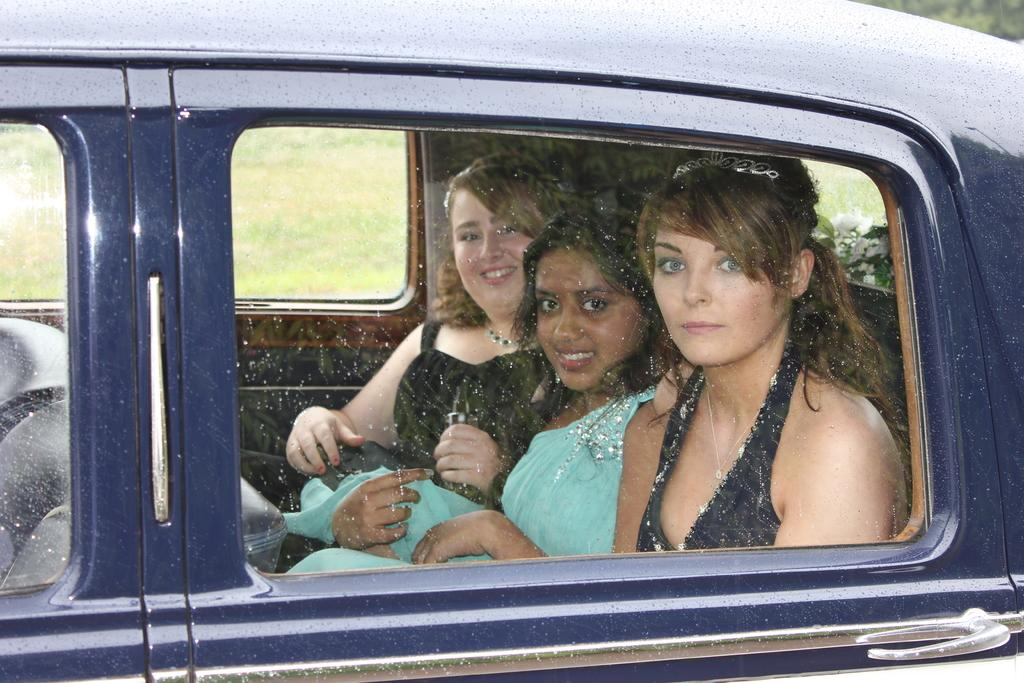How many people are in the image? There are three women in the image. What are the women doing in the image? The women are traveling in a car. What type of pickle is the driver eating while driving in the image? There is no pickle present in the image, and the driver is not eating anything. 